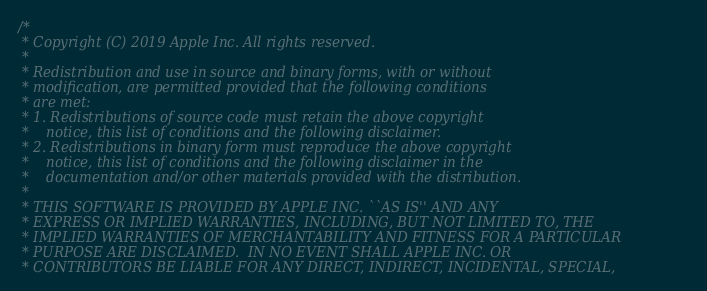Convert code to text. <code><loc_0><loc_0><loc_500><loc_500><_C++_>/*
 * Copyright (C) 2019 Apple Inc. All rights reserved.
 *
 * Redistribution and use in source and binary forms, with or without
 * modification, are permitted provided that the following conditions
 * are met:
 * 1. Redistributions of source code must retain the above copyright
 *    notice, this list of conditions and the following disclaimer.
 * 2. Redistributions in binary form must reproduce the above copyright
 *    notice, this list of conditions and the following disclaimer in the
 *    documentation and/or other materials provided with the distribution.
 *
 * THIS SOFTWARE IS PROVIDED BY APPLE INC. ``AS IS'' AND ANY
 * EXPRESS OR IMPLIED WARRANTIES, INCLUDING, BUT NOT LIMITED TO, THE
 * IMPLIED WARRANTIES OF MERCHANTABILITY AND FITNESS FOR A PARTICULAR
 * PURPOSE ARE DISCLAIMED.  IN NO EVENT SHALL APPLE INC. OR
 * CONTRIBUTORS BE LIABLE FOR ANY DIRECT, INDIRECT, INCIDENTAL, SPECIAL,</code> 